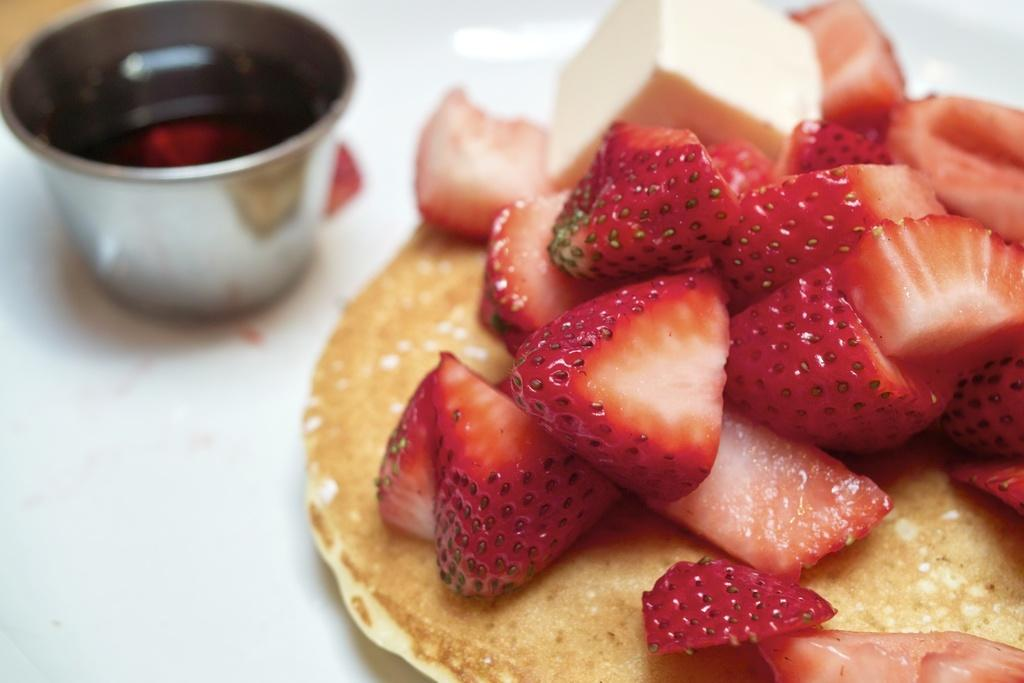What is on top of the pancake in the image? There are strawberry slices on the pancake. What is the bowl used for in the image? The purpose of the bowl is not specified in the image. What is located at the bottom of the image? There appears to be a plate at the bottom of the image. What type of needle is used to create the thrill in the image? There is no needle or thrill present in the image; it features a pancake with strawberry slices, a bowl, and a plate. 